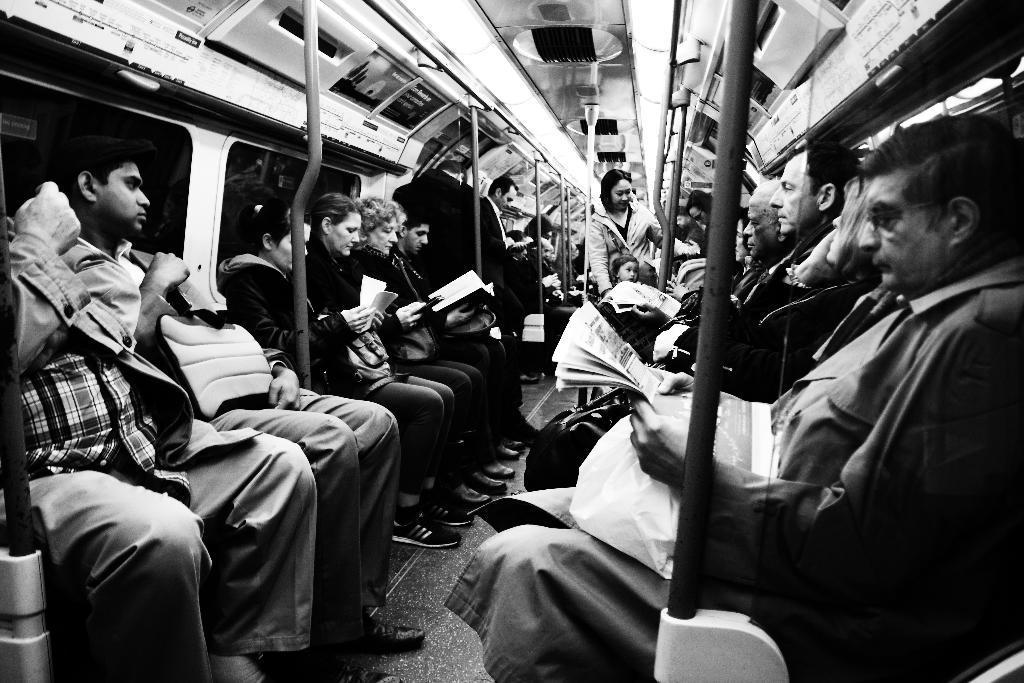How would you summarize this image in a sentence or two? In this image we can see many people sitting on an object and holding some objects in their hands. There are many poles in the image. There are few people standing in the image. 